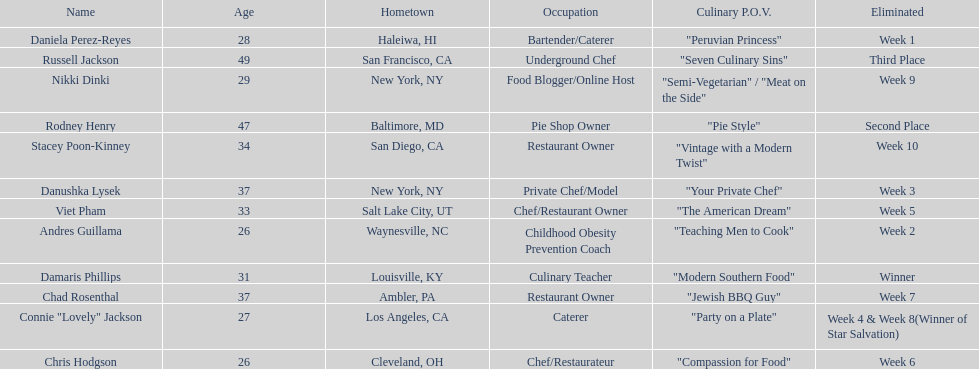Which contestant is the same age as chris hodgson? Andres Guillama. 